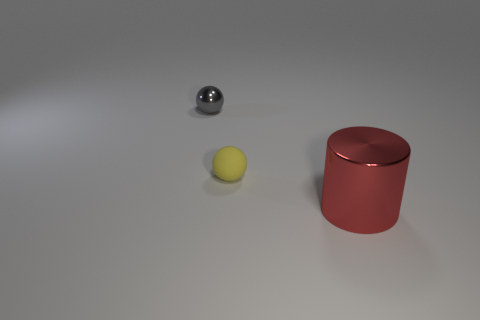Add 2 small gray cubes. How many objects exist? 5 Subtract all cylinders. How many objects are left? 2 Subtract 0 cyan cylinders. How many objects are left? 3 Subtract all small cyan shiny spheres. Subtract all spheres. How many objects are left? 1 Add 2 large red shiny cylinders. How many large red shiny cylinders are left? 3 Add 2 large cyan shiny balls. How many large cyan shiny balls exist? 2 